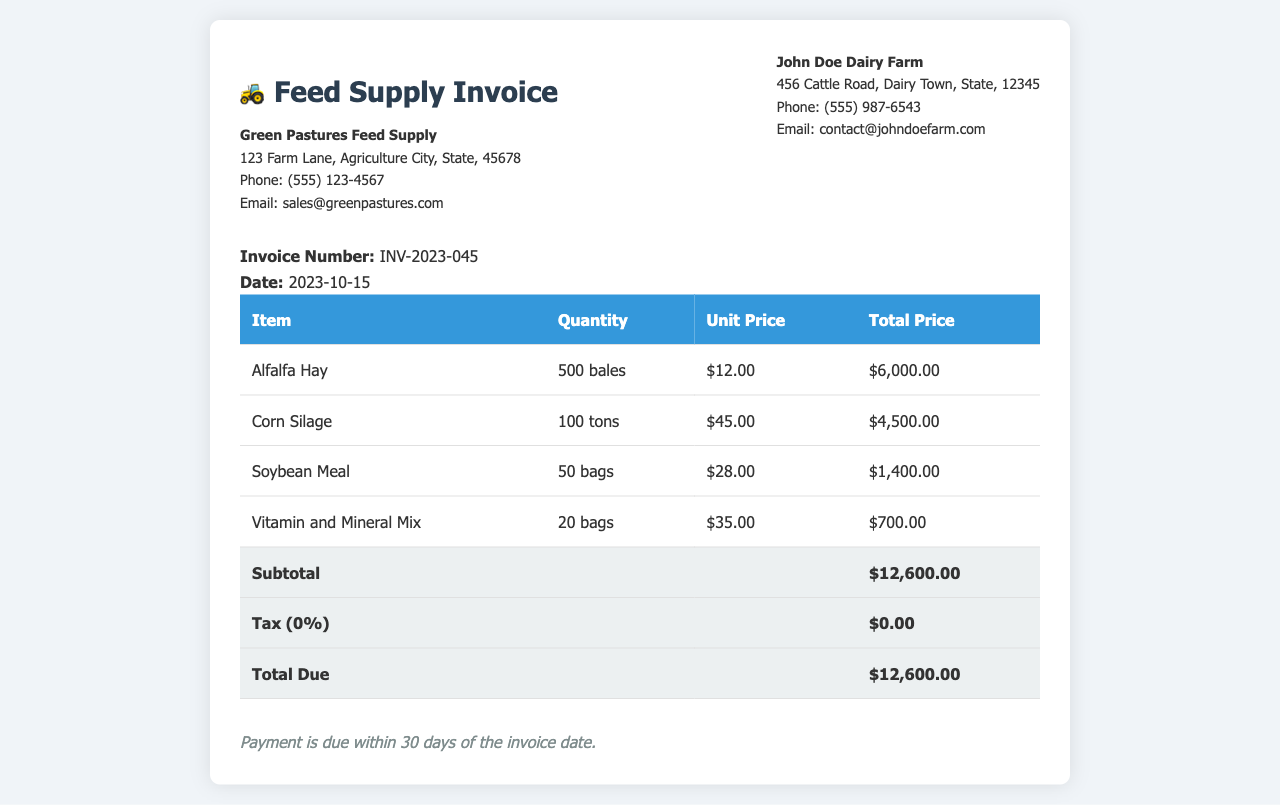What is the invoice number? The invoice number is a unique identifier for the invoice document, found in the header section.
Answer: INV-2023-045 What is the total due? The total due is the final amount that needs to be paid, calculated as subtotal plus tax.
Answer: $12,600.00 Who is the supplier of the feed? The supplier's name is listed at the top of the document, identifying the company that issued the invoice.
Answer: Green Pastures Feed Supply How many bales of Alfalfa Hay were ordered? This information can be found in the itemized table detailing the feed supplies.
Answer: 500 bales What is the unit price of Soybean Meal? The unit price is specified for each item in the invoice and is found in the respective row of the itemized table.
Answer: $28.00 What is the quantity of Corn Silage? This answer comes from the itemized listing, showing how much of this particular feed was ordered.
Answer: 100 tons What is the payment term for this invoice? Payment terms are stated at the bottom of the invoice, indicating when payment is expected.
Answer: Within 30 days What is the total price for Vitamin and Mineral Mix? The total price for each item is calculated in the itemized table and can be found in the corresponding row.
Answer: $700.00 